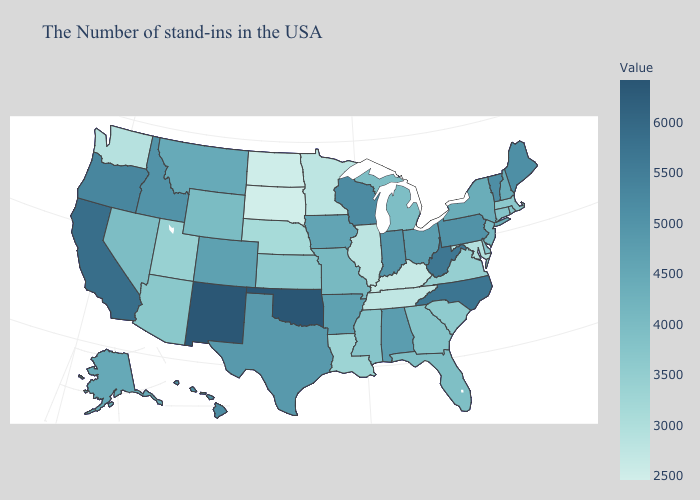Which states have the lowest value in the USA?
Quick response, please. South Dakota. Does Missouri have a higher value than Colorado?
Be succinct. No. Among the states that border Vermont , does New York have the highest value?
Concise answer only. No. Does Oklahoma have the highest value in the USA?
Give a very brief answer. Yes. Does South Dakota have the lowest value in the USA?
Write a very short answer. Yes. 